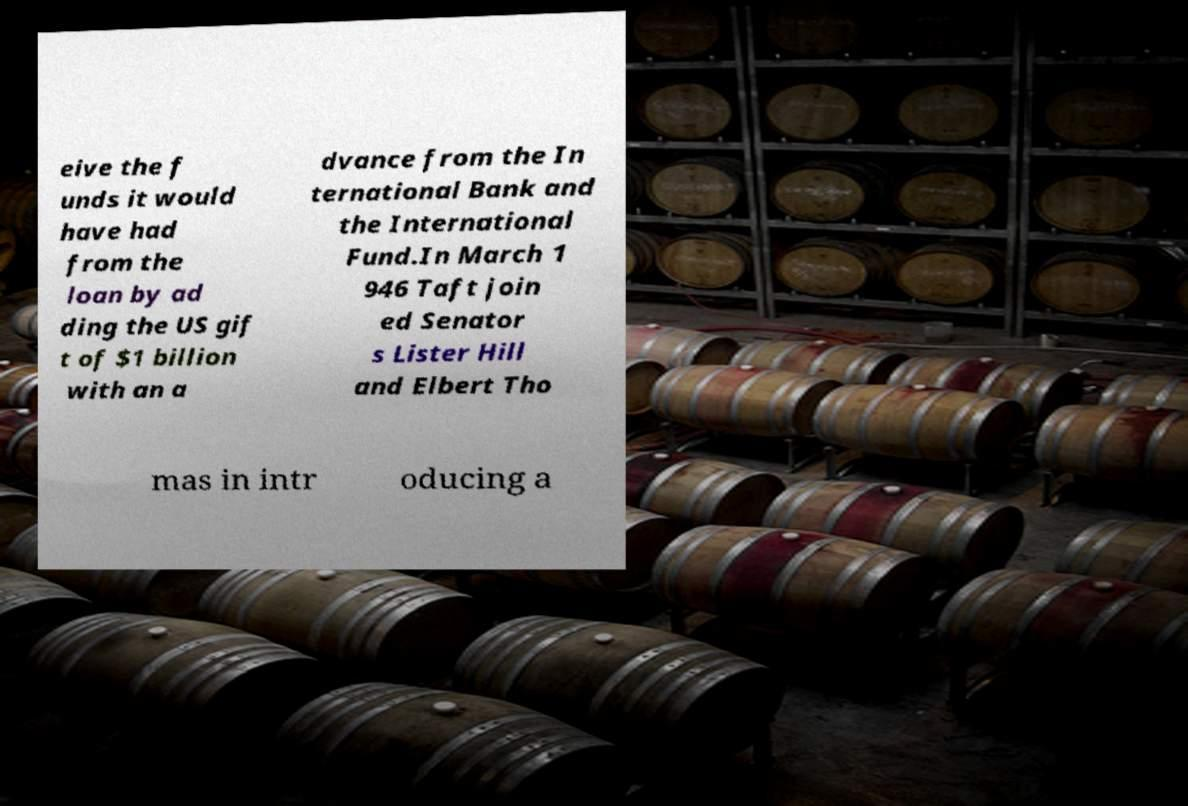Could you extract and type out the text from this image? eive the f unds it would have had from the loan by ad ding the US gif t of $1 billion with an a dvance from the In ternational Bank and the International Fund.In March 1 946 Taft join ed Senator s Lister Hill and Elbert Tho mas in intr oducing a 